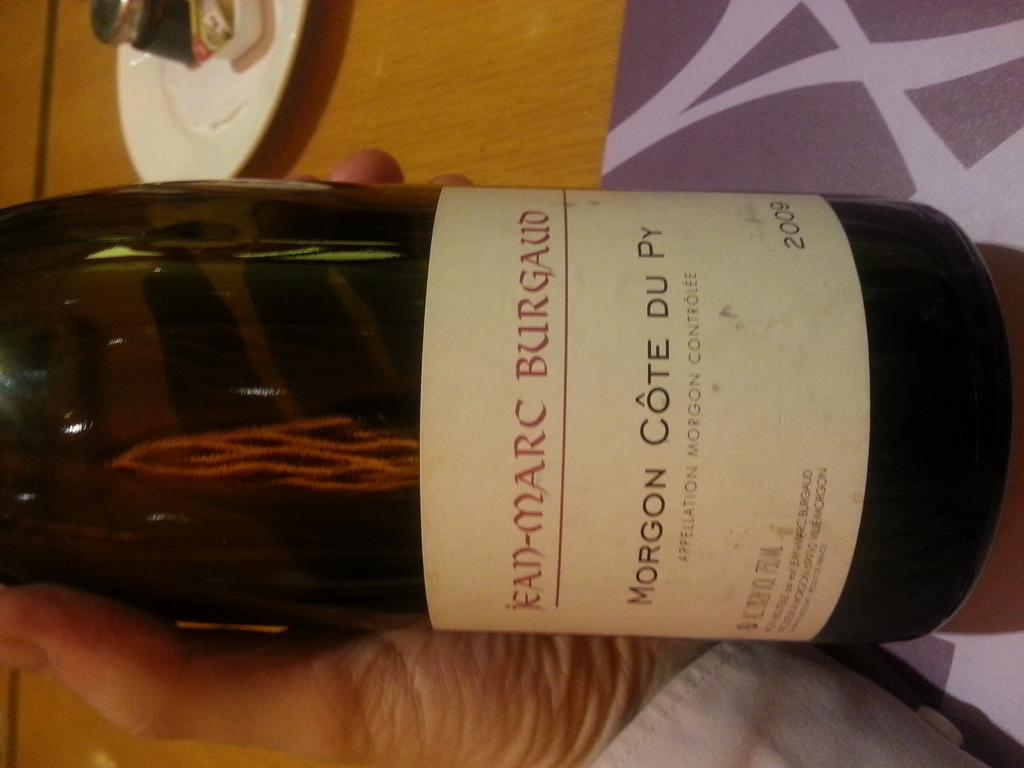<image>
Create a compact narrative representing the image presented. A person holds a bottle of wine from 2009. 